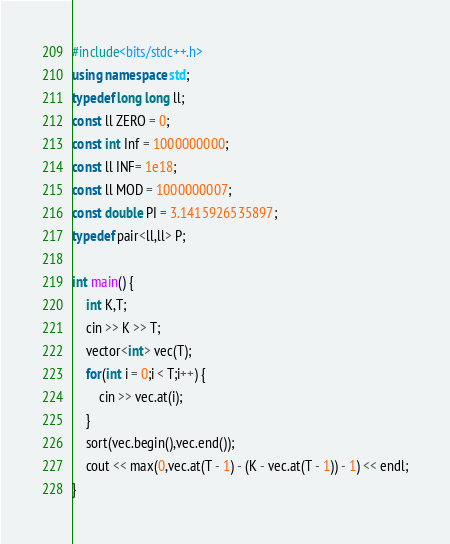Convert code to text. <code><loc_0><loc_0><loc_500><loc_500><_C++_>#include<bits/stdc++.h>
using namespace std;
typedef long long ll;
const ll ZERO = 0;
const int Inf = 1000000000;
const ll INF= 1e18;
const ll MOD = 1000000007;
const double PI = 3.1415926535897;
typedef pair<ll,ll> P;

int main() {
    int K,T;
    cin >> K >> T;
    vector<int> vec(T);
    for(int i = 0;i < T;i++) {
        cin >> vec.at(i);
    }
    sort(vec.begin(),vec.end());
    cout << max(0,vec.at(T - 1) - (K - vec.at(T - 1)) - 1) << endl;
}</code> 